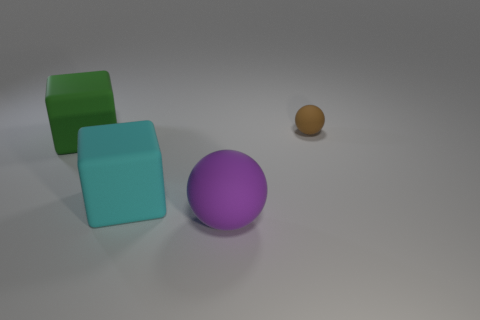How many blocks are either large green rubber objects or small objects?
Provide a short and direct response. 1. There is a ball that is in front of the large block to the right of the green block behind the large purple matte ball; what is it made of?
Ensure brevity in your answer.  Rubber. What number of other objects are there of the same size as the brown sphere?
Offer a terse response. 0. Is the number of purple objects in front of the large cyan thing greater than the number of big gray metal blocks?
Your response must be concise. Yes. The block that is the same size as the green matte object is what color?
Provide a short and direct response. Cyan. How many purple objects are in front of the matte ball right of the big rubber sphere?
Your response must be concise. 1. How many objects are either rubber blocks that are right of the green matte block or big purple things?
Offer a very short reply. 2. What number of big purple balls have the same material as the brown sphere?
Your response must be concise. 1. Are there the same number of big spheres that are to the left of the green object and big cyan rubber things?
Your response must be concise. No. There is a block left of the big cyan matte object; how big is it?
Your answer should be very brief. Large. 